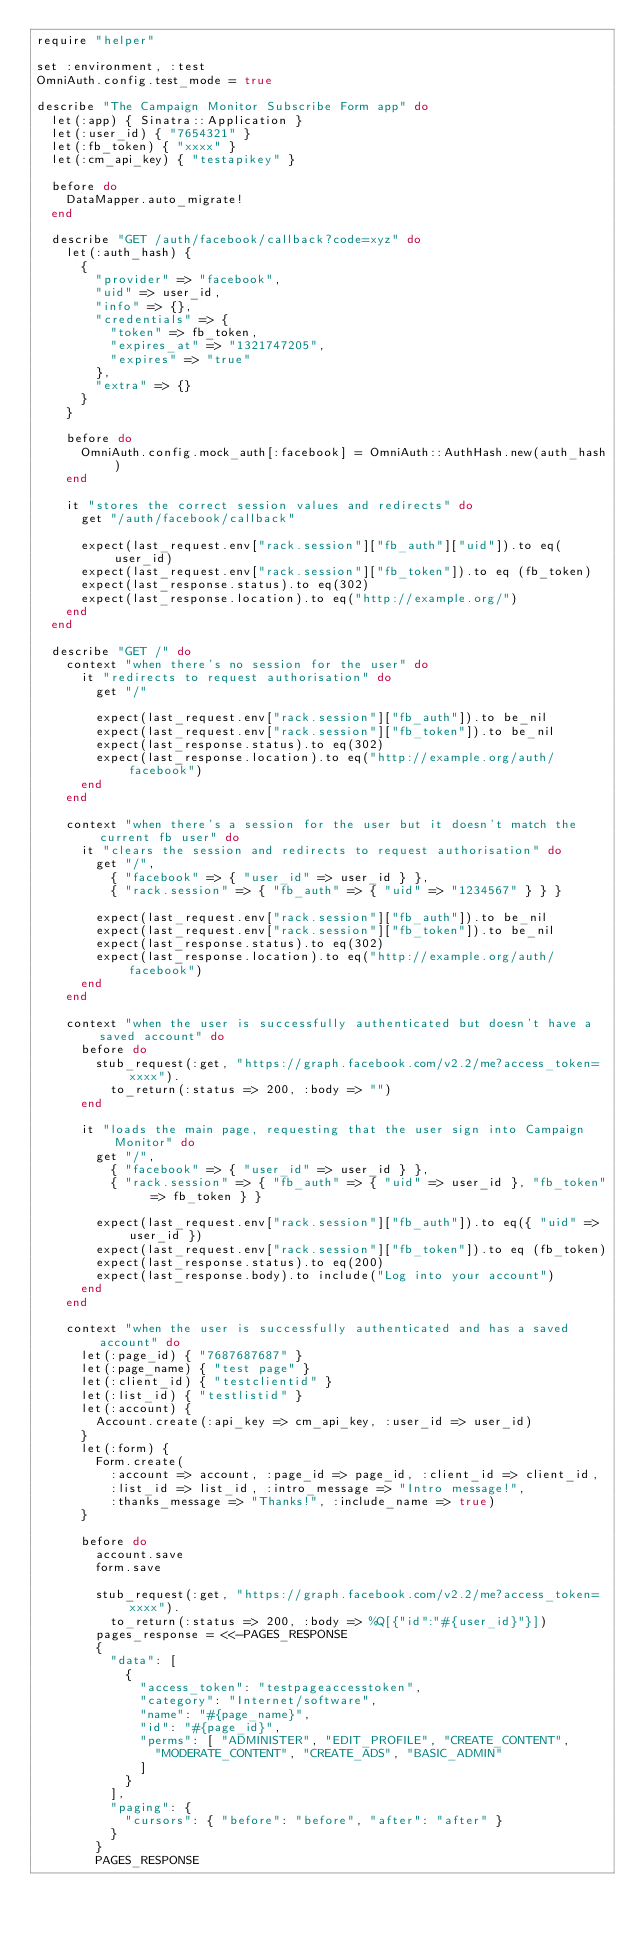<code> <loc_0><loc_0><loc_500><loc_500><_Ruby_>require "helper"

set :environment, :test
OmniAuth.config.test_mode = true

describe "The Campaign Monitor Subscribe Form app" do
  let(:app) { Sinatra::Application }
  let(:user_id) { "7654321" }
  let(:fb_token) { "xxxx" }
  let(:cm_api_key) { "testapikey" }

  before do
    DataMapper.auto_migrate!
  end

  describe "GET /auth/facebook/callback?code=xyz" do
    let(:auth_hash) {
      {
        "provider" => "facebook",
        "uid" => user_id,
        "info" => {},
        "credentials" => {
          "token" => fb_token,
          "expires_at" => "1321747205",
          "expires" => "true"
        },
        "extra" => {}
      }
    }

    before do
      OmniAuth.config.mock_auth[:facebook] = OmniAuth::AuthHash.new(auth_hash)
    end

    it "stores the correct session values and redirects" do
      get "/auth/facebook/callback"

      expect(last_request.env["rack.session"]["fb_auth"]["uid"]).to eq(user_id)
      expect(last_request.env["rack.session"]["fb_token"]).to eq (fb_token)
      expect(last_response.status).to eq(302)
      expect(last_response.location).to eq("http://example.org/")
    end
  end

  describe "GET /" do
    context "when there's no session for the user" do
      it "redirects to request authorisation" do
        get "/"

        expect(last_request.env["rack.session"]["fb_auth"]).to be_nil
        expect(last_request.env["rack.session"]["fb_token"]).to be_nil
        expect(last_response.status).to eq(302)
        expect(last_response.location).to eq("http://example.org/auth/facebook")
      end
    end

    context "when there's a session for the user but it doesn't match the current fb user" do
      it "clears the session and redirects to request authorisation" do
        get "/",
          { "facebook" => { "user_id" => user_id } },
          { "rack.session" => { "fb_auth" => { "uid" => "1234567" } } }

        expect(last_request.env["rack.session"]["fb_auth"]).to be_nil
        expect(last_request.env["rack.session"]["fb_token"]).to be_nil
        expect(last_response.status).to eq(302)
        expect(last_response.location).to eq("http://example.org/auth/facebook")
      end
    end

    context "when the user is successfully authenticated but doesn't have a saved account" do
      before do
        stub_request(:get, "https://graph.facebook.com/v2.2/me?access_token=xxxx").
          to_return(:status => 200, :body => "")
      end

      it "loads the main page, requesting that the user sign into Campaign Monitor" do
        get "/",
          { "facebook" => { "user_id" => user_id } },
          { "rack.session" => { "fb_auth" => { "uid" => user_id }, "fb_token" => fb_token } }

        expect(last_request.env["rack.session"]["fb_auth"]).to eq({ "uid" => user_id })
        expect(last_request.env["rack.session"]["fb_token"]).to eq (fb_token)
        expect(last_response.status).to eq(200)
        expect(last_response.body).to include("Log into your account")
      end
    end

    context "when the user is successfully authenticated and has a saved account" do
      let(:page_id) { "7687687687" }
      let(:page_name) { "test page" }
      let(:client_id) { "testclientid" }
      let(:list_id) { "testlistid" }
      let(:account) {
        Account.create(:api_key => cm_api_key, :user_id => user_id)
      }
      let(:form) {
        Form.create(
          :account => account, :page_id => page_id, :client_id => client_id,
          :list_id => list_id, :intro_message => "Intro message!",
          :thanks_message => "Thanks!", :include_name => true)
      }

      before do
        account.save
        form.save

        stub_request(:get, "https://graph.facebook.com/v2.2/me?access_token=xxxx").
          to_return(:status => 200, :body => %Q[{"id":"#{user_id}"}])
        pages_response = <<-PAGES_RESPONSE
        {
          "data": [
            {
              "access_token": "testpageaccesstoken",
              "category": "Internet/software",
              "name": "#{page_name}",
              "id": "#{page_id}",
              "perms": [ "ADMINISTER", "EDIT_PROFILE", "CREATE_CONTENT",
                "MODERATE_CONTENT", "CREATE_ADS", "BASIC_ADMIN"
              ]
            }
          ],
          "paging": {
            "cursors": { "before": "before", "after": "after" }
          }
        }
        PAGES_RESPONSE</code> 